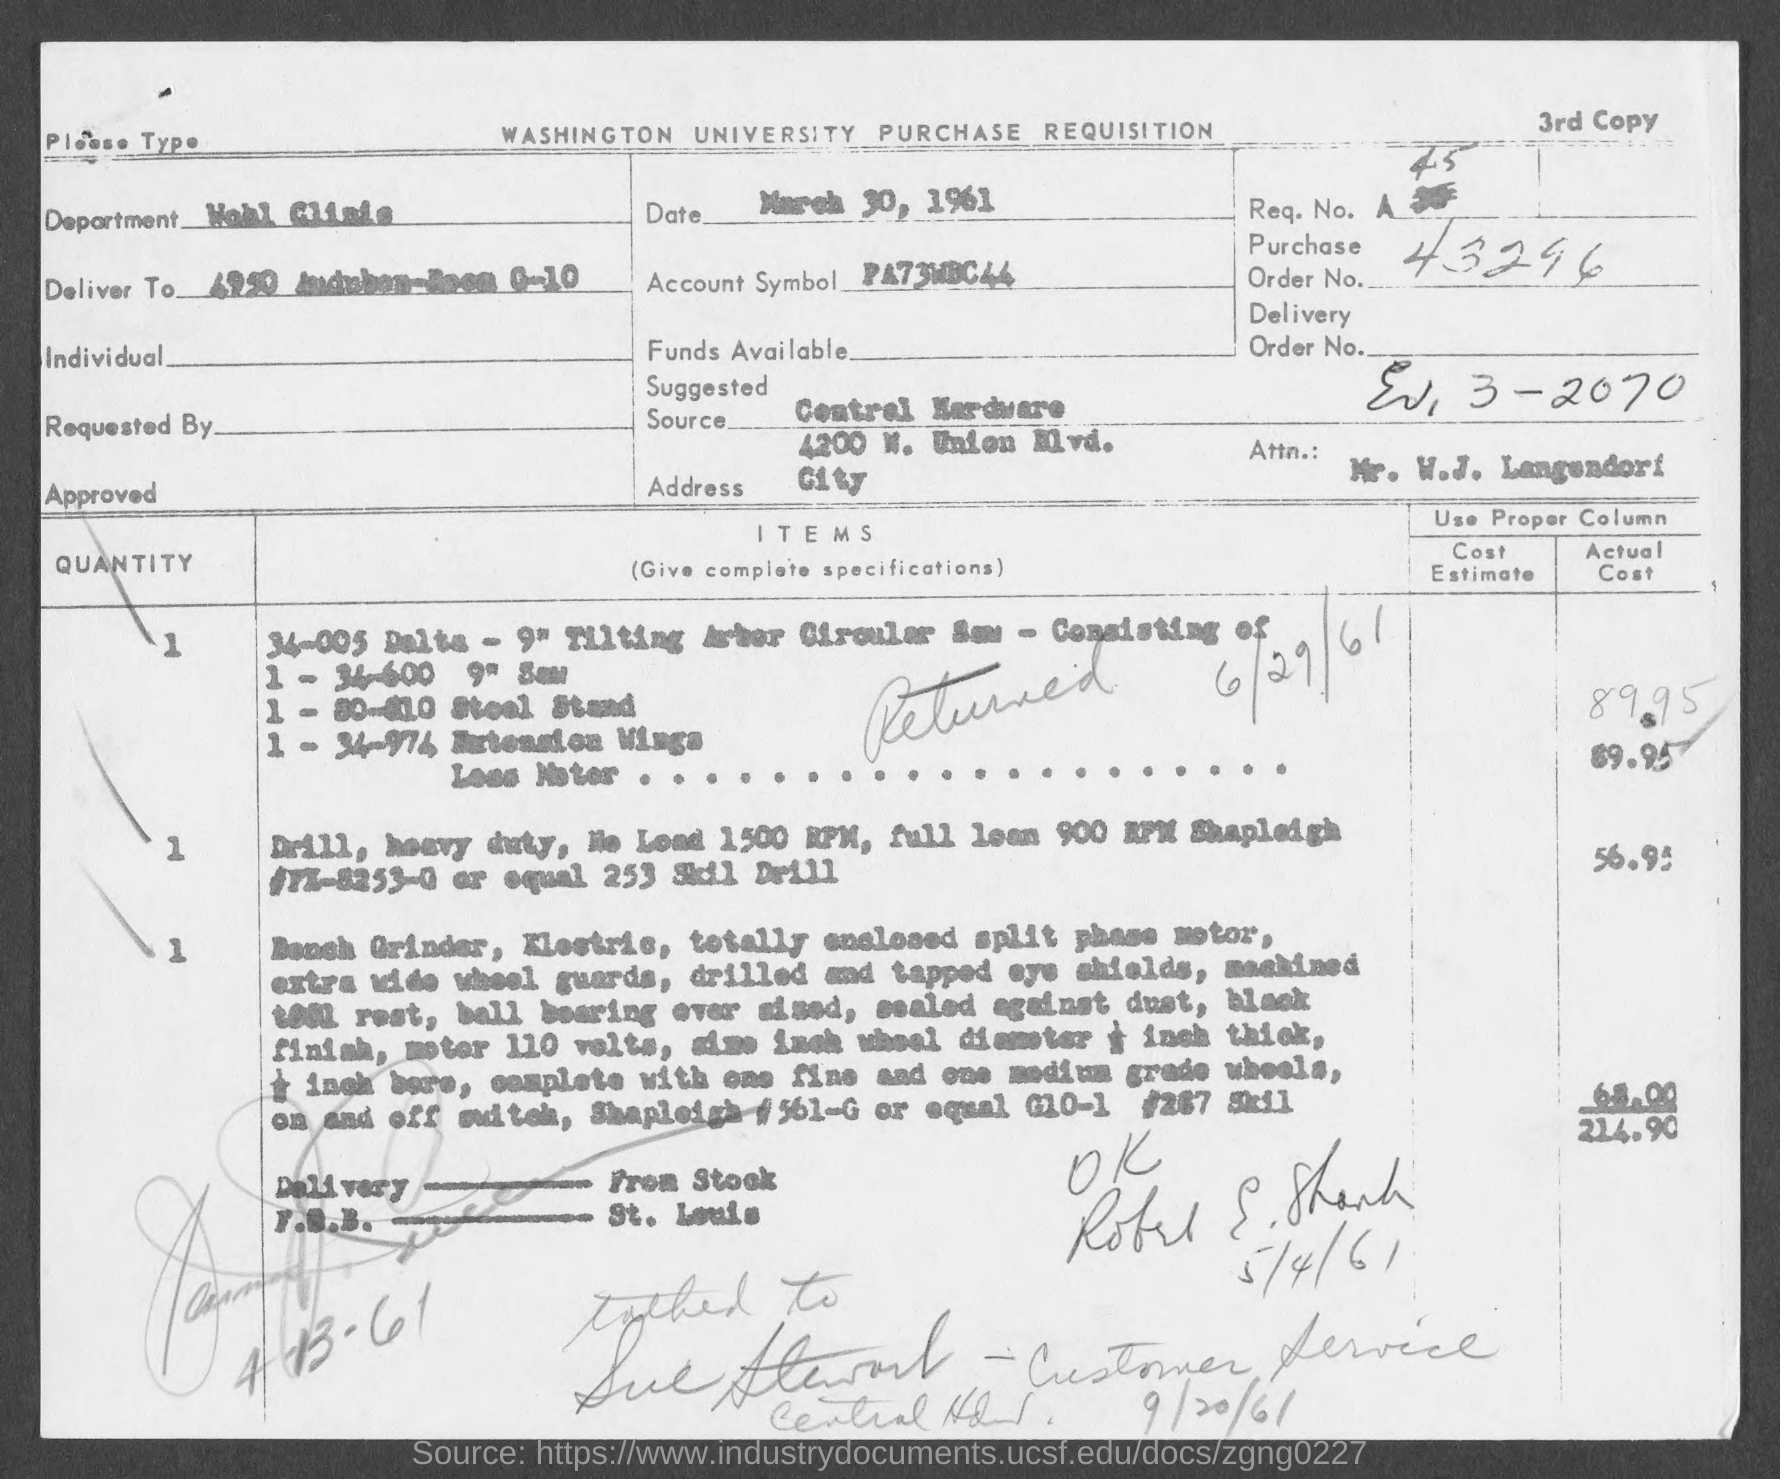What is the issued date of this document?
Provide a succinct answer. MARCH 30, 1961. What is the Purchase Order No. given in the document?
Your response must be concise. 43296. What is the account symbol mentioned in the document?
Offer a terse response. PA73WBC44. 